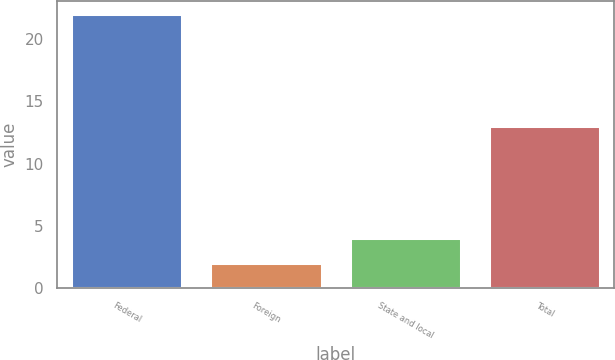Convert chart to OTSL. <chart><loc_0><loc_0><loc_500><loc_500><bar_chart><fcel>Federal<fcel>Foreign<fcel>State and local<fcel>Total<nl><fcel>22<fcel>2<fcel>4<fcel>13<nl></chart> 